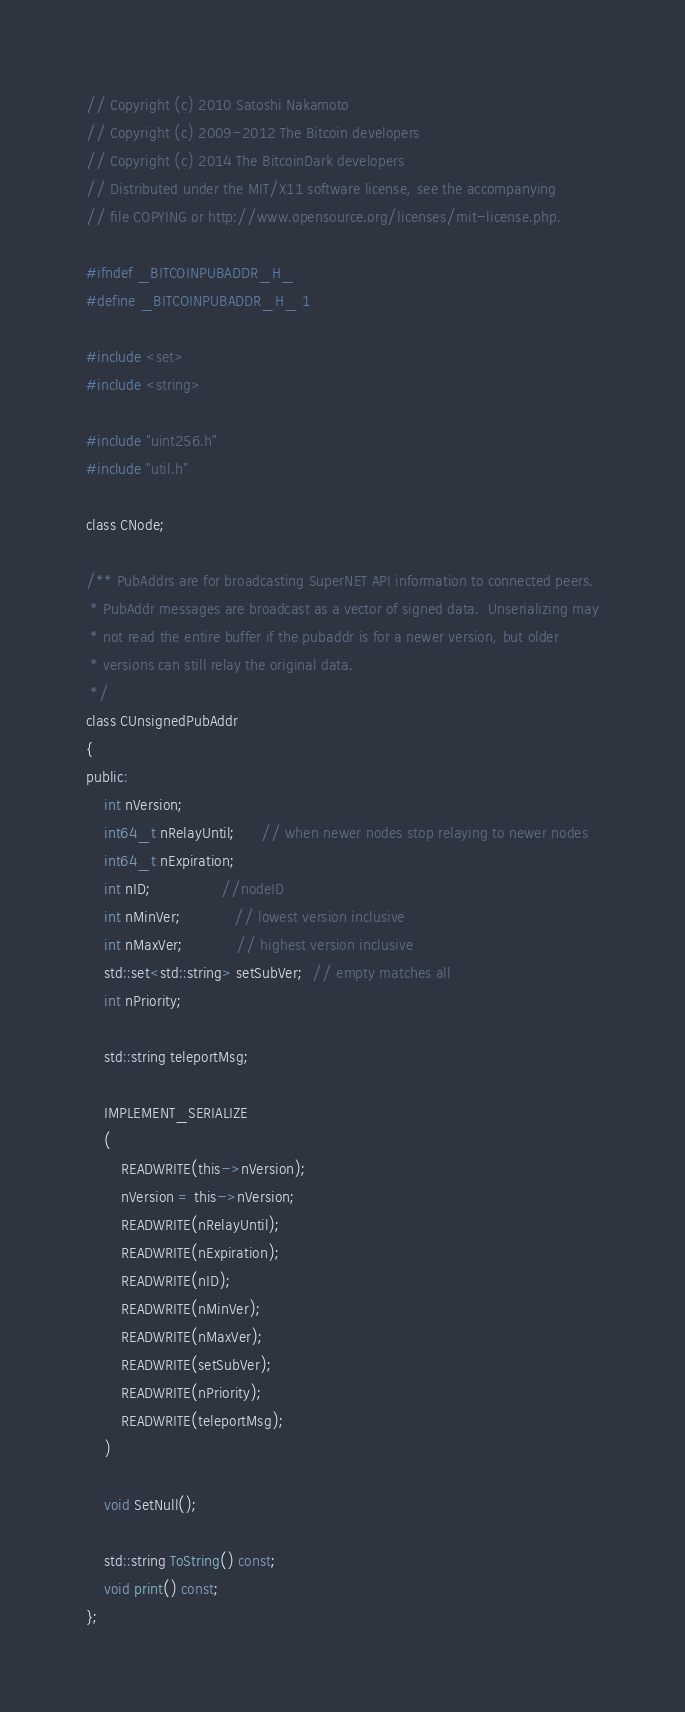<code> <loc_0><loc_0><loc_500><loc_500><_C_>
// Copyright (c) 2010 Satoshi Nakamoto
// Copyright (c) 2009-2012 The Bitcoin developers
// Copyright (c) 2014 The BitcoinDark developers
// Distributed under the MIT/X11 software license, see the accompanying
// file COPYING or http://www.opensource.org/licenses/mit-license.php.

#ifndef _BITCOINPUBADDR_H_
#define _BITCOINPUBADDR_H_ 1

#include <set>
#include <string>

#include "uint256.h"
#include "util.h"

class CNode;

/** PubAddrs are for broadcasting SuperNET API information to connected peers.
 * PubAddr messages are broadcast as a vector of signed data.  Unserializing may
 * not read the entire buffer if the pubaddr is for a newer version, but older
 * versions can still relay the original data.
 */
class CUnsignedPubAddr
{
public:
    int nVersion;
    int64_t nRelayUntil;      // when newer nodes stop relaying to newer nodes
    int64_t nExpiration;
    int nID;                //nodeID
    int nMinVer;            // lowest version inclusive
    int nMaxVer;            // highest version inclusive
    std::set<std::string> setSubVer;  // empty matches all
    int nPriority;

    std::string teleportMsg;

    IMPLEMENT_SERIALIZE
    (
        READWRITE(this->nVersion);
        nVersion = this->nVersion;
        READWRITE(nRelayUntil);
        READWRITE(nExpiration);
        READWRITE(nID);
        READWRITE(nMinVer);
        READWRITE(nMaxVer);
        READWRITE(setSubVer);
        READWRITE(nPriority);
        READWRITE(teleportMsg);
    )

    void SetNull();

    std::string ToString() const;
    void print() const;
};
</code> 